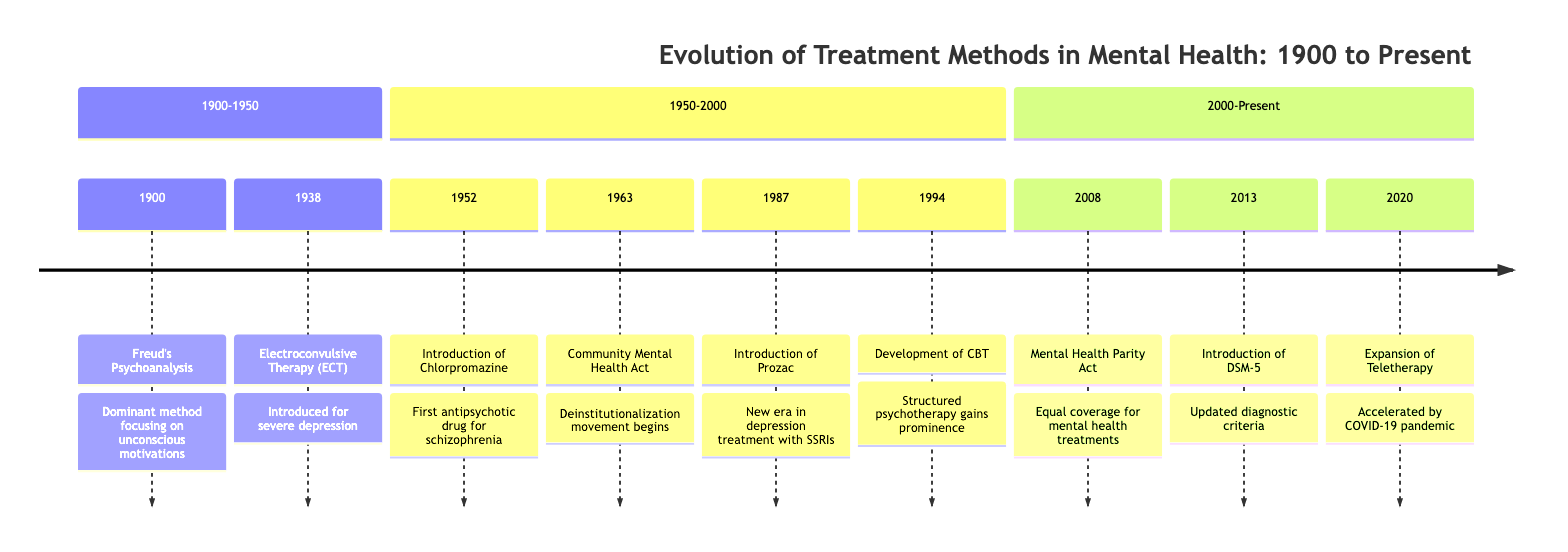What significant treatment method was introduced in 1900? The diagram states that Freud's Psychoanalysis was introduced in 1900, focusing on unconscious motivations and childhood experiences.
Answer: Freud's Psychoanalysis How many years apart were the introduction of Chlorpromazine and Prozac? Chlorpromazine was introduced in 1952 and Prozac in 1987. To find the difference, subtract 1952 from 1987, which gives us 35 years.
Answer: 35 years What impact did the Community Mental Health Act have? The diagram indicates that the Community Mental Health Act initiated the deinstitutionalization movement and led to the establishment of community mental health centers.
Answer: Deinstitutionalization movement What is the latest significant event listed in the timeline? According to the timeline, the most recent event is the expansion of teletherapy in 2020, which was accelerated by the COVID-19 pandemic.
Answer: Expansion of Teletherapy Which important mental health treatment was first introduced in 1938? The timeline notes that Electroconvulsive Therapy (ECT) was introduced in 1938 as a treatment for severe depression and other mental disorders.
Answer: Electroconvulsive Therapy (ECT) What edition of the Diagnostic and Statistical Manual of Mental Disorders was introduced in 2013? The timeline mentions that the American Psychiatric Association published the DSM-5 in 2013, providing updated classifications and criteria.
Answer: DSM-5 How many treatment milestones are shown in the section from 1950 to 2000? Upon reviewing the timeline section from 1950 to 2000, we see there are four significant treatment milestones including Chlorpromazine, the Community Mental Health Act, Prozac, and CBT.
Answer: Four milestones What event in 2008 required equal coverage for mental health treatments? The diagram states that the Mental Health Parity and Addiction Equity Act was passed in 2008, mandating equal coverage for mental health and substance use disorder treatments.
Answer: Mental Health Parity and Addiction Equity Act Which treatment method gained prominence in 1994? The timeline indicates that the development of Cognitive Behavioral Therapy (CBT) gained prominence in 1994 for its effectiveness across various mental health disorders.
Answer: Cognitive Behavioral Therapy (CBT) 